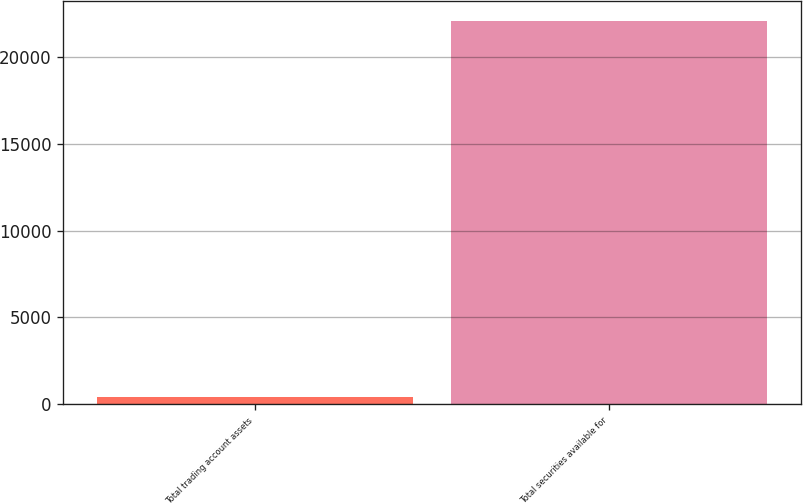<chart> <loc_0><loc_0><loc_500><loc_500><bar_chart><fcel>Total trading account assets<fcel>Total securities available for<nl><fcel>407<fcel>22111<nl></chart> 